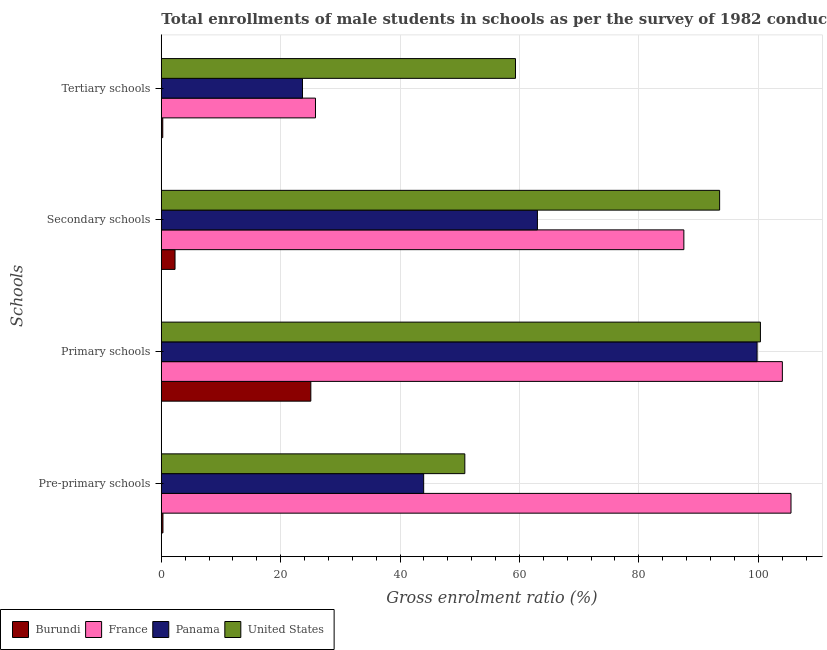How many different coloured bars are there?
Keep it short and to the point. 4. How many groups of bars are there?
Your response must be concise. 4. Are the number of bars per tick equal to the number of legend labels?
Offer a terse response. Yes. How many bars are there on the 4th tick from the bottom?
Ensure brevity in your answer.  4. What is the label of the 1st group of bars from the top?
Provide a short and direct response. Tertiary schools. What is the gross enrolment ratio(male) in pre-primary schools in United States?
Provide a succinct answer. 50.85. Across all countries, what is the maximum gross enrolment ratio(male) in pre-primary schools?
Make the answer very short. 105.49. Across all countries, what is the minimum gross enrolment ratio(male) in secondary schools?
Ensure brevity in your answer.  2.3. In which country was the gross enrolment ratio(male) in secondary schools minimum?
Offer a terse response. Burundi. What is the total gross enrolment ratio(male) in pre-primary schools in the graph?
Your answer should be very brief. 200.56. What is the difference between the gross enrolment ratio(male) in primary schools in Burundi and that in France?
Keep it short and to the point. -78.99. What is the difference between the gross enrolment ratio(male) in secondary schools in France and the gross enrolment ratio(male) in primary schools in Burundi?
Make the answer very short. 62.49. What is the average gross enrolment ratio(male) in pre-primary schools per country?
Ensure brevity in your answer.  50.14. What is the difference between the gross enrolment ratio(male) in pre-primary schools and gross enrolment ratio(male) in secondary schools in Panama?
Provide a succinct answer. -19.06. What is the ratio of the gross enrolment ratio(male) in pre-primary schools in United States to that in Panama?
Offer a terse response. 1.16. Is the gross enrolment ratio(male) in pre-primary schools in United States less than that in Burundi?
Offer a very short reply. No. Is the difference between the gross enrolment ratio(male) in secondary schools in France and Burundi greater than the difference between the gross enrolment ratio(male) in pre-primary schools in France and Burundi?
Your answer should be compact. No. What is the difference between the highest and the second highest gross enrolment ratio(male) in tertiary schools?
Your answer should be very brief. 33.5. What is the difference between the highest and the lowest gross enrolment ratio(male) in primary schools?
Your answer should be compact. 78.99. In how many countries, is the gross enrolment ratio(male) in primary schools greater than the average gross enrolment ratio(male) in primary schools taken over all countries?
Your answer should be very brief. 3. Is the sum of the gross enrolment ratio(male) in pre-primary schools in United States and France greater than the maximum gross enrolment ratio(male) in primary schools across all countries?
Offer a terse response. Yes. Is it the case that in every country, the sum of the gross enrolment ratio(male) in tertiary schools and gross enrolment ratio(male) in primary schools is greater than the sum of gross enrolment ratio(male) in pre-primary schools and gross enrolment ratio(male) in secondary schools?
Keep it short and to the point. No. What does the 4th bar from the top in Pre-primary schools represents?
Provide a succinct answer. Burundi. What does the 4th bar from the bottom in Tertiary schools represents?
Provide a short and direct response. United States. Is it the case that in every country, the sum of the gross enrolment ratio(male) in pre-primary schools and gross enrolment ratio(male) in primary schools is greater than the gross enrolment ratio(male) in secondary schools?
Give a very brief answer. Yes. How many countries are there in the graph?
Ensure brevity in your answer.  4. Does the graph contain any zero values?
Your answer should be very brief. No. Where does the legend appear in the graph?
Offer a terse response. Bottom left. How many legend labels are there?
Your answer should be very brief. 4. How are the legend labels stacked?
Keep it short and to the point. Horizontal. What is the title of the graph?
Offer a very short reply. Total enrollments of male students in schools as per the survey of 1982 conducted in different countries. What is the label or title of the Y-axis?
Your answer should be very brief. Schools. What is the Gross enrolment ratio (%) in Burundi in Pre-primary schools?
Offer a terse response. 0.27. What is the Gross enrolment ratio (%) of France in Pre-primary schools?
Give a very brief answer. 105.49. What is the Gross enrolment ratio (%) of Panama in Pre-primary schools?
Provide a short and direct response. 43.95. What is the Gross enrolment ratio (%) of United States in Pre-primary schools?
Make the answer very short. 50.85. What is the Gross enrolment ratio (%) in Burundi in Primary schools?
Your answer should be very brief. 25.05. What is the Gross enrolment ratio (%) of France in Primary schools?
Offer a terse response. 104.04. What is the Gross enrolment ratio (%) of Panama in Primary schools?
Make the answer very short. 99.81. What is the Gross enrolment ratio (%) in United States in Primary schools?
Offer a terse response. 100.36. What is the Gross enrolment ratio (%) of Burundi in Secondary schools?
Provide a succinct answer. 2.3. What is the Gross enrolment ratio (%) of France in Secondary schools?
Make the answer very short. 87.54. What is the Gross enrolment ratio (%) of Panama in Secondary schools?
Provide a succinct answer. 63.01. What is the Gross enrolment ratio (%) of United States in Secondary schools?
Provide a succinct answer. 93.53. What is the Gross enrolment ratio (%) of Burundi in Tertiary schools?
Offer a terse response. 0.24. What is the Gross enrolment ratio (%) in France in Tertiary schools?
Keep it short and to the point. 25.83. What is the Gross enrolment ratio (%) in Panama in Tertiary schools?
Your answer should be compact. 23.65. What is the Gross enrolment ratio (%) of United States in Tertiary schools?
Provide a succinct answer. 59.33. Across all Schools, what is the maximum Gross enrolment ratio (%) in Burundi?
Your response must be concise. 25.05. Across all Schools, what is the maximum Gross enrolment ratio (%) of France?
Offer a very short reply. 105.49. Across all Schools, what is the maximum Gross enrolment ratio (%) of Panama?
Your answer should be very brief. 99.81. Across all Schools, what is the maximum Gross enrolment ratio (%) in United States?
Your response must be concise. 100.36. Across all Schools, what is the minimum Gross enrolment ratio (%) of Burundi?
Provide a short and direct response. 0.24. Across all Schools, what is the minimum Gross enrolment ratio (%) in France?
Provide a short and direct response. 25.83. Across all Schools, what is the minimum Gross enrolment ratio (%) in Panama?
Your answer should be compact. 23.65. Across all Schools, what is the minimum Gross enrolment ratio (%) of United States?
Provide a short and direct response. 50.85. What is the total Gross enrolment ratio (%) of Burundi in the graph?
Offer a terse response. 27.86. What is the total Gross enrolment ratio (%) of France in the graph?
Your response must be concise. 322.89. What is the total Gross enrolment ratio (%) of Panama in the graph?
Your response must be concise. 230.41. What is the total Gross enrolment ratio (%) of United States in the graph?
Your answer should be very brief. 304.07. What is the difference between the Gross enrolment ratio (%) of Burundi in Pre-primary schools and that in Primary schools?
Ensure brevity in your answer.  -24.77. What is the difference between the Gross enrolment ratio (%) of France in Pre-primary schools and that in Primary schools?
Offer a very short reply. 1.45. What is the difference between the Gross enrolment ratio (%) in Panama in Pre-primary schools and that in Primary schools?
Keep it short and to the point. -55.86. What is the difference between the Gross enrolment ratio (%) in United States in Pre-primary schools and that in Primary schools?
Ensure brevity in your answer.  -49.52. What is the difference between the Gross enrolment ratio (%) in Burundi in Pre-primary schools and that in Secondary schools?
Make the answer very short. -2.02. What is the difference between the Gross enrolment ratio (%) in France in Pre-primary schools and that in Secondary schools?
Your answer should be compact. 17.95. What is the difference between the Gross enrolment ratio (%) in Panama in Pre-primary schools and that in Secondary schools?
Give a very brief answer. -19.06. What is the difference between the Gross enrolment ratio (%) in United States in Pre-primary schools and that in Secondary schools?
Your response must be concise. -42.68. What is the difference between the Gross enrolment ratio (%) of Burundi in Pre-primary schools and that in Tertiary schools?
Provide a succinct answer. 0.03. What is the difference between the Gross enrolment ratio (%) in France in Pre-primary schools and that in Tertiary schools?
Your response must be concise. 79.66. What is the difference between the Gross enrolment ratio (%) in Panama in Pre-primary schools and that in Tertiary schools?
Keep it short and to the point. 20.3. What is the difference between the Gross enrolment ratio (%) of United States in Pre-primary schools and that in Tertiary schools?
Your answer should be very brief. -8.48. What is the difference between the Gross enrolment ratio (%) of Burundi in Primary schools and that in Secondary schools?
Provide a succinct answer. 22.75. What is the difference between the Gross enrolment ratio (%) in France in Primary schools and that in Secondary schools?
Provide a short and direct response. 16.5. What is the difference between the Gross enrolment ratio (%) of Panama in Primary schools and that in Secondary schools?
Offer a very short reply. 36.8. What is the difference between the Gross enrolment ratio (%) of United States in Primary schools and that in Secondary schools?
Make the answer very short. 6.83. What is the difference between the Gross enrolment ratio (%) of Burundi in Primary schools and that in Tertiary schools?
Offer a very short reply. 24.8. What is the difference between the Gross enrolment ratio (%) in France in Primary schools and that in Tertiary schools?
Give a very brief answer. 78.21. What is the difference between the Gross enrolment ratio (%) of Panama in Primary schools and that in Tertiary schools?
Offer a very short reply. 76.16. What is the difference between the Gross enrolment ratio (%) of United States in Primary schools and that in Tertiary schools?
Offer a terse response. 41.03. What is the difference between the Gross enrolment ratio (%) of Burundi in Secondary schools and that in Tertiary schools?
Provide a short and direct response. 2.05. What is the difference between the Gross enrolment ratio (%) of France in Secondary schools and that in Tertiary schools?
Offer a terse response. 61.71. What is the difference between the Gross enrolment ratio (%) in Panama in Secondary schools and that in Tertiary schools?
Give a very brief answer. 39.36. What is the difference between the Gross enrolment ratio (%) of United States in Secondary schools and that in Tertiary schools?
Keep it short and to the point. 34.2. What is the difference between the Gross enrolment ratio (%) of Burundi in Pre-primary schools and the Gross enrolment ratio (%) of France in Primary schools?
Ensure brevity in your answer.  -103.76. What is the difference between the Gross enrolment ratio (%) of Burundi in Pre-primary schools and the Gross enrolment ratio (%) of Panama in Primary schools?
Provide a short and direct response. -99.53. What is the difference between the Gross enrolment ratio (%) of Burundi in Pre-primary schools and the Gross enrolment ratio (%) of United States in Primary schools?
Offer a very short reply. -100.09. What is the difference between the Gross enrolment ratio (%) in France in Pre-primary schools and the Gross enrolment ratio (%) in Panama in Primary schools?
Offer a terse response. 5.68. What is the difference between the Gross enrolment ratio (%) of France in Pre-primary schools and the Gross enrolment ratio (%) of United States in Primary schools?
Offer a very short reply. 5.12. What is the difference between the Gross enrolment ratio (%) in Panama in Pre-primary schools and the Gross enrolment ratio (%) in United States in Primary schools?
Keep it short and to the point. -56.41. What is the difference between the Gross enrolment ratio (%) in Burundi in Pre-primary schools and the Gross enrolment ratio (%) in France in Secondary schools?
Make the answer very short. -87.26. What is the difference between the Gross enrolment ratio (%) in Burundi in Pre-primary schools and the Gross enrolment ratio (%) in Panama in Secondary schools?
Your answer should be very brief. -62.73. What is the difference between the Gross enrolment ratio (%) in Burundi in Pre-primary schools and the Gross enrolment ratio (%) in United States in Secondary schools?
Provide a short and direct response. -93.26. What is the difference between the Gross enrolment ratio (%) of France in Pre-primary schools and the Gross enrolment ratio (%) of Panama in Secondary schools?
Provide a short and direct response. 42.48. What is the difference between the Gross enrolment ratio (%) of France in Pre-primary schools and the Gross enrolment ratio (%) of United States in Secondary schools?
Your response must be concise. 11.96. What is the difference between the Gross enrolment ratio (%) in Panama in Pre-primary schools and the Gross enrolment ratio (%) in United States in Secondary schools?
Your response must be concise. -49.58. What is the difference between the Gross enrolment ratio (%) of Burundi in Pre-primary schools and the Gross enrolment ratio (%) of France in Tertiary schools?
Your response must be concise. -25.55. What is the difference between the Gross enrolment ratio (%) of Burundi in Pre-primary schools and the Gross enrolment ratio (%) of Panama in Tertiary schools?
Provide a succinct answer. -23.38. What is the difference between the Gross enrolment ratio (%) of Burundi in Pre-primary schools and the Gross enrolment ratio (%) of United States in Tertiary schools?
Give a very brief answer. -59.06. What is the difference between the Gross enrolment ratio (%) of France in Pre-primary schools and the Gross enrolment ratio (%) of Panama in Tertiary schools?
Offer a terse response. 81.84. What is the difference between the Gross enrolment ratio (%) in France in Pre-primary schools and the Gross enrolment ratio (%) in United States in Tertiary schools?
Keep it short and to the point. 46.16. What is the difference between the Gross enrolment ratio (%) of Panama in Pre-primary schools and the Gross enrolment ratio (%) of United States in Tertiary schools?
Your answer should be very brief. -15.38. What is the difference between the Gross enrolment ratio (%) in Burundi in Primary schools and the Gross enrolment ratio (%) in France in Secondary schools?
Offer a very short reply. -62.49. What is the difference between the Gross enrolment ratio (%) of Burundi in Primary schools and the Gross enrolment ratio (%) of Panama in Secondary schools?
Offer a terse response. -37.96. What is the difference between the Gross enrolment ratio (%) in Burundi in Primary schools and the Gross enrolment ratio (%) in United States in Secondary schools?
Your answer should be compact. -68.48. What is the difference between the Gross enrolment ratio (%) of France in Primary schools and the Gross enrolment ratio (%) of Panama in Secondary schools?
Make the answer very short. 41.03. What is the difference between the Gross enrolment ratio (%) of France in Primary schools and the Gross enrolment ratio (%) of United States in Secondary schools?
Provide a short and direct response. 10.51. What is the difference between the Gross enrolment ratio (%) in Panama in Primary schools and the Gross enrolment ratio (%) in United States in Secondary schools?
Keep it short and to the point. 6.28. What is the difference between the Gross enrolment ratio (%) of Burundi in Primary schools and the Gross enrolment ratio (%) of France in Tertiary schools?
Your answer should be compact. -0.78. What is the difference between the Gross enrolment ratio (%) of Burundi in Primary schools and the Gross enrolment ratio (%) of Panama in Tertiary schools?
Provide a short and direct response. 1.4. What is the difference between the Gross enrolment ratio (%) in Burundi in Primary schools and the Gross enrolment ratio (%) in United States in Tertiary schools?
Make the answer very short. -34.28. What is the difference between the Gross enrolment ratio (%) in France in Primary schools and the Gross enrolment ratio (%) in Panama in Tertiary schools?
Give a very brief answer. 80.39. What is the difference between the Gross enrolment ratio (%) in France in Primary schools and the Gross enrolment ratio (%) in United States in Tertiary schools?
Your answer should be very brief. 44.71. What is the difference between the Gross enrolment ratio (%) of Panama in Primary schools and the Gross enrolment ratio (%) of United States in Tertiary schools?
Ensure brevity in your answer.  40.48. What is the difference between the Gross enrolment ratio (%) in Burundi in Secondary schools and the Gross enrolment ratio (%) in France in Tertiary schools?
Your answer should be compact. -23.53. What is the difference between the Gross enrolment ratio (%) of Burundi in Secondary schools and the Gross enrolment ratio (%) of Panama in Tertiary schools?
Give a very brief answer. -21.35. What is the difference between the Gross enrolment ratio (%) of Burundi in Secondary schools and the Gross enrolment ratio (%) of United States in Tertiary schools?
Offer a very short reply. -57.03. What is the difference between the Gross enrolment ratio (%) of France in Secondary schools and the Gross enrolment ratio (%) of Panama in Tertiary schools?
Keep it short and to the point. 63.89. What is the difference between the Gross enrolment ratio (%) of France in Secondary schools and the Gross enrolment ratio (%) of United States in Tertiary schools?
Ensure brevity in your answer.  28.21. What is the difference between the Gross enrolment ratio (%) in Panama in Secondary schools and the Gross enrolment ratio (%) in United States in Tertiary schools?
Provide a short and direct response. 3.68. What is the average Gross enrolment ratio (%) of Burundi per Schools?
Your answer should be compact. 6.97. What is the average Gross enrolment ratio (%) in France per Schools?
Ensure brevity in your answer.  80.72. What is the average Gross enrolment ratio (%) of Panama per Schools?
Your answer should be very brief. 57.6. What is the average Gross enrolment ratio (%) in United States per Schools?
Provide a short and direct response. 76.02. What is the difference between the Gross enrolment ratio (%) in Burundi and Gross enrolment ratio (%) in France in Pre-primary schools?
Your response must be concise. -105.21. What is the difference between the Gross enrolment ratio (%) in Burundi and Gross enrolment ratio (%) in Panama in Pre-primary schools?
Your answer should be compact. -43.68. What is the difference between the Gross enrolment ratio (%) of Burundi and Gross enrolment ratio (%) of United States in Pre-primary schools?
Provide a succinct answer. -50.57. What is the difference between the Gross enrolment ratio (%) in France and Gross enrolment ratio (%) in Panama in Pre-primary schools?
Your answer should be very brief. 61.54. What is the difference between the Gross enrolment ratio (%) of France and Gross enrolment ratio (%) of United States in Pre-primary schools?
Provide a succinct answer. 54.64. What is the difference between the Gross enrolment ratio (%) in Panama and Gross enrolment ratio (%) in United States in Pre-primary schools?
Provide a short and direct response. -6.9. What is the difference between the Gross enrolment ratio (%) of Burundi and Gross enrolment ratio (%) of France in Primary schools?
Ensure brevity in your answer.  -78.99. What is the difference between the Gross enrolment ratio (%) of Burundi and Gross enrolment ratio (%) of Panama in Primary schools?
Provide a succinct answer. -74.76. What is the difference between the Gross enrolment ratio (%) of Burundi and Gross enrolment ratio (%) of United States in Primary schools?
Offer a very short reply. -75.32. What is the difference between the Gross enrolment ratio (%) of France and Gross enrolment ratio (%) of Panama in Primary schools?
Give a very brief answer. 4.23. What is the difference between the Gross enrolment ratio (%) of France and Gross enrolment ratio (%) of United States in Primary schools?
Keep it short and to the point. 3.68. What is the difference between the Gross enrolment ratio (%) in Panama and Gross enrolment ratio (%) in United States in Primary schools?
Ensure brevity in your answer.  -0.56. What is the difference between the Gross enrolment ratio (%) of Burundi and Gross enrolment ratio (%) of France in Secondary schools?
Offer a terse response. -85.24. What is the difference between the Gross enrolment ratio (%) of Burundi and Gross enrolment ratio (%) of Panama in Secondary schools?
Give a very brief answer. -60.71. What is the difference between the Gross enrolment ratio (%) of Burundi and Gross enrolment ratio (%) of United States in Secondary schools?
Keep it short and to the point. -91.23. What is the difference between the Gross enrolment ratio (%) in France and Gross enrolment ratio (%) in Panama in Secondary schools?
Give a very brief answer. 24.53. What is the difference between the Gross enrolment ratio (%) in France and Gross enrolment ratio (%) in United States in Secondary schools?
Offer a terse response. -5.99. What is the difference between the Gross enrolment ratio (%) of Panama and Gross enrolment ratio (%) of United States in Secondary schools?
Offer a very short reply. -30.52. What is the difference between the Gross enrolment ratio (%) in Burundi and Gross enrolment ratio (%) in France in Tertiary schools?
Your answer should be very brief. -25.58. What is the difference between the Gross enrolment ratio (%) of Burundi and Gross enrolment ratio (%) of Panama in Tertiary schools?
Your answer should be very brief. -23.41. What is the difference between the Gross enrolment ratio (%) of Burundi and Gross enrolment ratio (%) of United States in Tertiary schools?
Keep it short and to the point. -59.09. What is the difference between the Gross enrolment ratio (%) of France and Gross enrolment ratio (%) of Panama in Tertiary schools?
Provide a short and direct response. 2.18. What is the difference between the Gross enrolment ratio (%) of France and Gross enrolment ratio (%) of United States in Tertiary schools?
Ensure brevity in your answer.  -33.5. What is the difference between the Gross enrolment ratio (%) of Panama and Gross enrolment ratio (%) of United States in Tertiary schools?
Provide a succinct answer. -35.68. What is the ratio of the Gross enrolment ratio (%) of Burundi in Pre-primary schools to that in Primary schools?
Provide a succinct answer. 0.01. What is the ratio of the Gross enrolment ratio (%) of France in Pre-primary schools to that in Primary schools?
Your answer should be compact. 1.01. What is the ratio of the Gross enrolment ratio (%) of Panama in Pre-primary schools to that in Primary schools?
Provide a succinct answer. 0.44. What is the ratio of the Gross enrolment ratio (%) in United States in Pre-primary schools to that in Primary schools?
Provide a succinct answer. 0.51. What is the ratio of the Gross enrolment ratio (%) of Burundi in Pre-primary schools to that in Secondary schools?
Offer a very short reply. 0.12. What is the ratio of the Gross enrolment ratio (%) of France in Pre-primary schools to that in Secondary schools?
Offer a very short reply. 1.21. What is the ratio of the Gross enrolment ratio (%) of Panama in Pre-primary schools to that in Secondary schools?
Your response must be concise. 0.7. What is the ratio of the Gross enrolment ratio (%) in United States in Pre-primary schools to that in Secondary schools?
Offer a very short reply. 0.54. What is the ratio of the Gross enrolment ratio (%) in Burundi in Pre-primary schools to that in Tertiary schools?
Your response must be concise. 1.12. What is the ratio of the Gross enrolment ratio (%) in France in Pre-primary schools to that in Tertiary schools?
Make the answer very short. 4.08. What is the ratio of the Gross enrolment ratio (%) in Panama in Pre-primary schools to that in Tertiary schools?
Make the answer very short. 1.86. What is the ratio of the Gross enrolment ratio (%) of United States in Pre-primary schools to that in Tertiary schools?
Provide a short and direct response. 0.86. What is the ratio of the Gross enrolment ratio (%) of Burundi in Primary schools to that in Secondary schools?
Offer a very short reply. 10.9. What is the ratio of the Gross enrolment ratio (%) of France in Primary schools to that in Secondary schools?
Provide a short and direct response. 1.19. What is the ratio of the Gross enrolment ratio (%) of Panama in Primary schools to that in Secondary schools?
Make the answer very short. 1.58. What is the ratio of the Gross enrolment ratio (%) in United States in Primary schools to that in Secondary schools?
Make the answer very short. 1.07. What is the ratio of the Gross enrolment ratio (%) in Burundi in Primary schools to that in Tertiary schools?
Offer a very short reply. 102.85. What is the ratio of the Gross enrolment ratio (%) in France in Primary schools to that in Tertiary schools?
Ensure brevity in your answer.  4.03. What is the ratio of the Gross enrolment ratio (%) in Panama in Primary schools to that in Tertiary schools?
Your response must be concise. 4.22. What is the ratio of the Gross enrolment ratio (%) in United States in Primary schools to that in Tertiary schools?
Offer a very short reply. 1.69. What is the ratio of the Gross enrolment ratio (%) of Burundi in Secondary schools to that in Tertiary schools?
Give a very brief answer. 9.44. What is the ratio of the Gross enrolment ratio (%) in France in Secondary schools to that in Tertiary schools?
Provide a succinct answer. 3.39. What is the ratio of the Gross enrolment ratio (%) in Panama in Secondary schools to that in Tertiary schools?
Your answer should be compact. 2.66. What is the ratio of the Gross enrolment ratio (%) in United States in Secondary schools to that in Tertiary schools?
Give a very brief answer. 1.58. What is the difference between the highest and the second highest Gross enrolment ratio (%) of Burundi?
Give a very brief answer. 22.75. What is the difference between the highest and the second highest Gross enrolment ratio (%) of France?
Provide a short and direct response. 1.45. What is the difference between the highest and the second highest Gross enrolment ratio (%) of Panama?
Provide a short and direct response. 36.8. What is the difference between the highest and the second highest Gross enrolment ratio (%) in United States?
Make the answer very short. 6.83. What is the difference between the highest and the lowest Gross enrolment ratio (%) of Burundi?
Make the answer very short. 24.8. What is the difference between the highest and the lowest Gross enrolment ratio (%) of France?
Ensure brevity in your answer.  79.66. What is the difference between the highest and the lowest Gross enrolment ratio (%) in Panama?
Keep it short and to the point. 76.16. What is the difference between the highest and the lowest Gross enrolment ratio (%) of United States?
Make the answer very short. 49.52. 